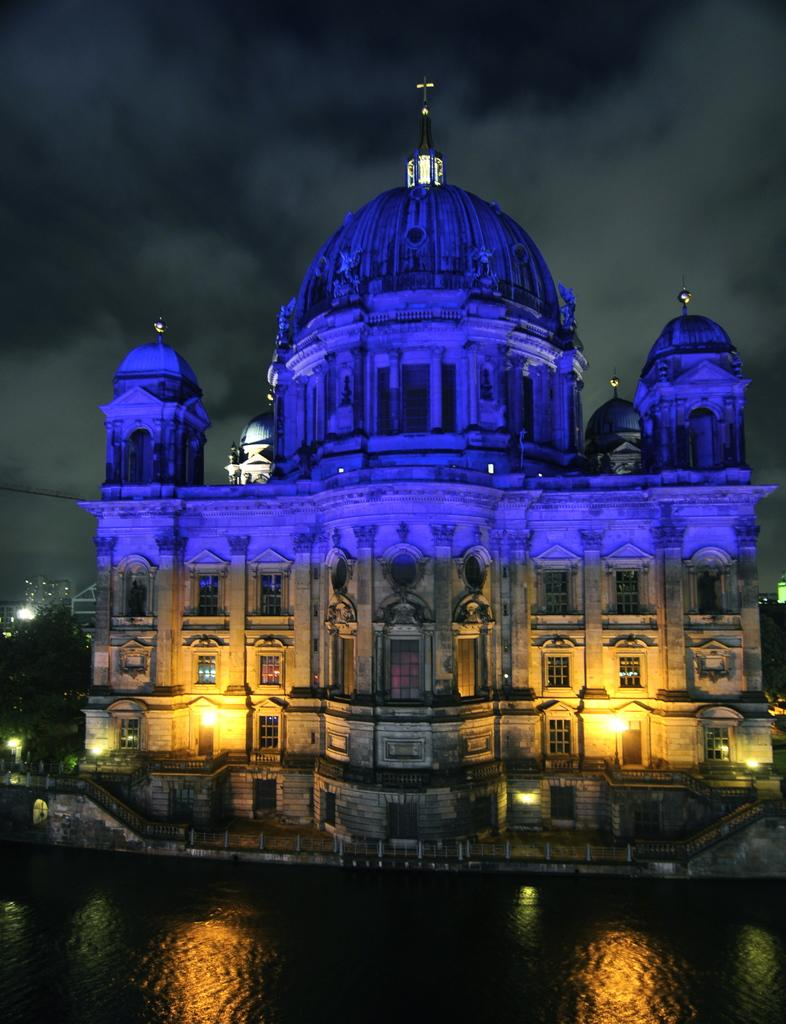What type of structure is in the image? There is a building in the image. What features can be seen on the building? The building has windows and lights. What is in front of the building? There is water in front of the building. What can be seen in the background of the image? The sky is visible in the background of the image. What type of pies are being served in the building in the image? There is no indication of pies or any food being served in the building in the image. 